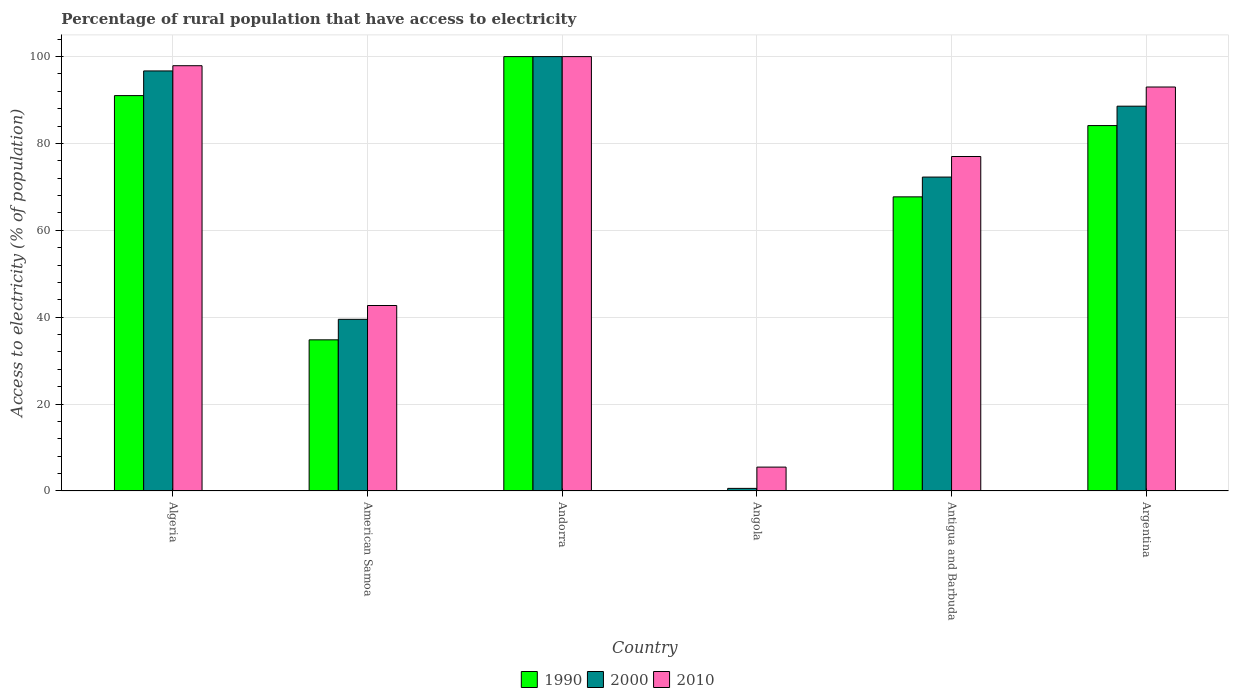Are the number of bars per tick equal to the number of legend labels?
Provide a short and direct response. Yes. How many bars are there on the 1st tick from the left?
Offer a very short reply. 3. How many bars are there on the 4th tick from the right?
Provide a succinct answer. 3. What is the label of the 1st group of bars from the left?
Ensure brevity in your answer.  Algeria. In how many cases, is the number of bars for a given country not equal to the number of legend labels?
Your answer should be compact. 0. What is the percentage of rural population that have access to electricity in 2010 in American Samoa?
Make the answer very short. 42.7. In which country was the percentage of rural population that have access to electricity in 2000 maximum?
Your answer should be compact. Andorra. In which country was the percentage of rural population that have access to electricity in 1990 minimum?
Your response must be concise. Angola. What is the total percentage of rural population that have access to electricity in 2010 in the graph?
Offer a very short reply. 416.1. What is the difference between the percentage of rural population that have access to electricity in 1990 in Andorra and that in Antigua and Barbuda?
Your answer should be very brief. 32.29. What is the difference between the percentage of rural population that have access to electricity in 1990 in Algeria and the percentage of rural population that have access to electricity in 2000 in Angola?
Your response must be concise. 90.42. What is the average percentage of rural population that have access to electricity in 1990 per country?
Provide a short and direct response. 62.96. What is the difference between the percentage of rural population that have access to electricity of/in 1990 and percentage of rural population that have access to electricity of/in 2010 in Argentina?
Your answer should be very brief. -8.88. What is the ratio of the percentage of rural population that have access to electricity in 2010 in American Samoa to that in Angola?
Your response must be concise. 7.76. What is the difference between the highest and the second highest percentage of rural population that have access to electricity in 1990?
Give a very brief answer. -8.98. What is the difference between the highest and the lowest percentage of rural population that have access to electricity in 1990?
Your answer should be compact. 99.9. In how many countries, is the percentage of rural population that have access to electricity in 2000 greater than the average percentage of rural population that have access to electricity in 2000 taken over all countries?
Make the answer very short. 4. Is the sum of the percentage of rural population that have access to electricity in 2010 in Antigua and Barbuda and Argentina greater than the maximum percentage of rural population that have access to electricity in 2000 across all countries?
Your answer should be compact. Yes. What does the 1st bar from the left in American Samoa represents?
Provide a short and direct response. 1990. Are all the bars in the graph horizontal?
Your response must be concise. No. How many countries are there in the graph?
Offer a terse response. 6. Are the values on the major ticks of Y-axis written in scientific E-notation?
Your response must be concise. No. Does the graph contain any zero values?
Your response must be concise. No. Where does the legend appear in the graph?
Offer a very short reply. Bottom center. How many legend labels are there?
Give a very brief answer. 3. How are the legend labels stacked?
Keep it short and to the point. Horizontal. What is the title of the graph?
Offer a terse response. Percentage of rural population that have access to electricity. Does "1993" appear as one of the legend labels in the graph?
Offer a terse response. No. What is the label or title of the X-axis?
Your answer should be very brief. Country. What is the label or title of the Y-axis?
Offer a terse response. Access to electricity (% of population). What is the Access to electricity (% of population) in 1990 in Algeria?
Make the answer very short. 91.02. What is the Access to electricity (% of population) in 2000 in Algeria?
Provide a succinct answer. 96.7. What is the Access to electricity (% of population) of 2010 in Algeria?
Give a very brief answer. 97.9. What is the Access to electricity (% of population) of 1990 in American Samoa?
Keep it short and to the point. 34.8. What is the Access to electricity (% of population) in 2000 in American Samoa?
Offer a very short reply. 39.52. What is the Access to electricity (% of population) in 2010 in American Samoa?
Your response must be concise. 42.7. What is the Access to electricity (% of population) of 1990 in Andorra?
Your answer should be very brief. 100. What is the Access to electricity (% of population) of 2010 in Andorra?
Ensure brevity in your answer.  100. What is the Access to electricity (% of population) of 1990 in Angola?
Provide a short and direct response. 0.1. What is the Access to electricity (% of population) in 2000 in Angola?
Provide a short and direct response. 0.6. What is the Access to electricity (% of population) in 1990 in Antigua and Barbuda?
Make the answer very short. 67.71. What is the Access to electricity (% of population) in 2000 in Antigua and Barbuda?
Keep it short and to the point. 72.27. What is the Access to electricity (% of population) in 2010 in Antigua and Barbuda?
Your response must be concise. 77. What is the Access to electricity (% of population) in 1990 in Argentina?
Make the answer very short. 84.12. What is the Access to electricity (% of population) in 2000 in Argentina?
Provide a succinct answer. 88.59. What is the Access to electricity (% of population) of 2010 in Argentina?
Your answer should be very brief. 93. What is the total Access to electricity (% of population) in 1990 in the graph?
Your answer should be compact. 377.75. What is the total Access to electricity (% of population) of 2000 in the graph?
Offer a very short reply. 397.67. What is the total Access to electricity (% of population) of 2010 in the graph?
Your answer should be compact. 416.1. What is the difference between the Access to electricity (% of population) of 1990 in Algeria and that in American Samoa?
Give a very brief answer. 56.22. What is the difference between the Access to electricity (% of population) of 2000 in Algeria and that in American Samoa?
Your answer should be compact. 57.18. What is the difference between the Access to electricity (% of population) of 2010 in Algeria and that in American Samoa?
Give a very brief answer. 55.2. What is the difference between the Access to electricity (% of population) in 1990 in Algeria and that in Andorra?
Keep it short and to the point. -8.98. What is the difference between the Access to electricity (% of population) in 2010 in Algeria and that in Andorra?
Offer a very short reply. -2.1. What is the difference between the Access to electricity (% of population) of 1990 in Algeria and that in Angola?
Give a very brief answer. 90.92. What is the difference between the Access to electricity (% of population) in 2000 in Algeria and that in Angola?
Offer a very short reply. 96.1. What is the difference between the Access to electricity (% of population) of 2010 in Algeria and that in Angola?
Offer a very short reply. 92.4. What is the difference between the Access to electricity (% of population) of 1990 in Algeria and that in Antigua and Barbuda?
Offer a very short reply. 23.31. What is the difference between the Access to electricity (% of population) of 2000 in Algeria and that in Antigua and Barbuda?
Your response must be concise. 24.43. What is the difference between the Access to electricity (% of population) in 2010 in Algeria and that in Antigua and Barbuda?
Offer a very short reply. 20.9. What is the difference between the Access to electricity (% of population) of 1990 in Algeria and that in Argentina?
Keep it short and to the point. 6.9. What is the difference between the Access to electricity (% of population) of 2000 in Algeria and that in Argentina?
Ensure brevity in your answer.  8.11. What is the difference between the Access to electricity (% of population) of 2010 in Algeria and that in Argentina?
Give a very brief answer. 4.9. What is the difference between the Access to electricity (% of population) in 1990 in American Samoa and that in Andorra?
Offer a terse response. -65.2. What is the difference between the Access to electricity (% of population) in 2000 in American Samoa and that in Andorra?
Give a very brief answer. -60.48. What is the difference between the Access to electricity (% of population) of 2010 in American Samoa and that in Andorra?
Your answer should be very brief. -57.3. What is the difference between the Access to electricity (% of population) of 1990 in American Samoa and that in Angola?
Ensure brevity in your answer.  34.7. What is the difference between the Access to electricity (% of population) in 2000 in American Samoa and that in Angola?
Provide a succinct answer. 38.92. What is the difference between the Access to electricity (% of population) in 2010 in American Samoa and that in Angola?
Keep it short and to the point. 37.2. What is the difference between the Access to electricity (% of population) of 1990 in American Samoa and that in Antigua and Barbuda?
Ensure brevity in your answer.  -32.91. What is the difference between the Access to electricity (% of population) in 2000 in American Samoa and that in Antigua and Barbuda?
Keep it short and to the point. -32.74. What is the difference between the Access to electricity (% of population) in 2010 in American Samoa and that in Antigua and Barbuda?
Offer a terse response. -34.3. What is the difference between the Access to electricity (% of population) of 1990 in American Samoa and that in Argentina?
Ensure brevity in your answer.  -49.32. What is the difference between the Access to electricity (% of population) of 2000 in American Samoa and that in Argentina?
Make the answer very short. -49.07. What is the difference between the Access to electricity (% of population) of 2010 in American Samoa and that in Argentina?
Keep it short and to the point. -50.3. What is the difference between the Access to electricity (% of population) in 1990 in Andorra and that in Angola?
Provide a succinct answer. 99.9. What is the difference between the Access to electricity (% of population) in 2000 in Andorra and that in Angola?
Give a very brief answer. 99.4. What is the difference between the Access to electricity (% of population) in 2010 in Andorra and that in Angola?
Your response must be concise. 94.5. What is the difference between the Access to electricity (% of population) in 1990 in Andorra and that in Antigua and Barbuda?
Make the answer very short. 32.29. What is the difference between the Access to electricity (% of population) in 2000 in Andorra and that in Antigua and Barbuda?
Keep it short and to the point. 27.73. What is the difference between the Access to electricity (% of population) in 2010 in Andorra and that in Antigua and Barbuda?
Your answer should be compact. 23. What is the difference between the Access to electricity (% of population) in 1990 in Andorra and that in Argentina?
Provide a succinct answer. 15.88. What is the difference between the Access to electricity (% of population) in 2000 in Andorra and that in Argentina?
Offer a very short reply. 11.41. What is the difference between the Access to electricity (% of population) of 1990 in Angola and that in Antigua and Barbuda?
Keep it short and to the point. -67.61. What is the difference between the Access to electricity (% of population) in 2000 in Angola and that in Antigua and Barbuda?
Your answer should be compact. -71.67. What is the difference between the Access to electricity (% of population) of 2010 in Angola and that in Antigua and Barbuda?
Your answer should be compact. -71.5. What is the difference between the Access to electricity (% of population) of 1990 in Angola and that in Argentina?
Your answer should be very brief. -84.02. What is the difference between the Access to electricity (% of population) of 2000 in Angola and that in Argentina?
Provide a succinct answer. -87.99. What is the difference between the Access to electricity (% of population) of 2010 in Angola and that in Argentina?
Provide a succinct answer. -87.5. What is the difference between the Access to electricity (% of population) of 1990 in Antigua and Barbuda and that in Argentina?
Offer a terse response. -16.41. What is the difference between the Access to electricity (% of population) in 2000 in Antigua and Barbuda and that in Argentina?
Offer a terse response. -16.32. What is the difference between the Access to electricity (% of population) in 1990 in Algeria and the Access to electricity (% of population) in 2000 in American Samoa?
Your answer should be compact. 51.5. What is the difference between the Access to electricity (% of population) of 1990 in Algeria and the Access to electricity (% of population) of 2010 in American Samoa?
Your answer should be compact. 48.32. What is the difference between the Access to electricity (% of population) of 2000 in Algeria and the Access to electricity (% of population) of 2010 in American Samoa?
Your answer should be compact. 54. What is the difference between the Access to electricity (% of population) of 1990 in Algeria and the Access to electricity (% of population) of 2000 in Andorra?
Your response must be concise. -8.98. What is the difference between the Access to electricity (% of population) of 1990 in Algeria and the Access to electricity (% of population) of 2010 in Andorra?
Provide a short and direct response. -8.98. What is the difference between the Access to electricity (% of population) of 1990 in Algeria and the Access to electricity (% of population) of 2000 in Angola?
Provide a short and direct response. 90.42. What is the difference between the Access to electricity (% of population) in 1990 in Algeria and the Access to electricity (% of population) in 2010 in Angola?
Keep it short and to the point. 85.52. What is the difference between the Access to electricity (% of population) in 2000 in Algeria and the Access to electricity (% of population) in 2010 in Angola?
Your answer should be very brief. 91.2. What is the difference between the Access to electricity (% of population) of 1990 in Algeria and the Access to electricity (% of population) of 2000 in Antigua and Barbuda?
Offer a terse response. 18.75. What is the difference between the Access to electricity (% of population) of 1990 in Algeria and the Access to electricity (% of population) of 2010 in Antigua and Barbuda?
Give a very brief answer. 14.02. What is the difference between the Access to electricity (% of population) in 2000 in Algeria and the Access to electricity (% of population) in 2010 in Antigua and Barbuda?
Ensure brevity in your answer.  19.7. What is the difference between the Access to electricity (% of population) of 1990 in Algeria and the Access to electricity (% of population) of 2000 in Argentina?
Your answer should be compact. 2.43. What is the difference between the Access to electricity (% of population) in 1990 in Algeria and the Access to electricity (% of population) in 2010 in Argentina?
Make the answer very short. -1.98. What is the difference between the Access to electricity (% of population) in 2000 in Algeria and the Access to electricity (% of population) in 2010 in Argentina?
Keep it short and to the point. 3.7. What is the difference between the Access to electricity (% of population) in 1990 in American Samoa and the Access to electricity (% of population) in 2000 in Andorra?
Provide a short and direct response. -65.2. What is the difference between the Access to electricity (% of population) in 1990 in American Samoa and the Access to electricity (% of population) in 2010 in Andorra?
Offer a terse response. -65.2. What is the difference between the Access to electricity (% of population) of 2000 in American Samoa and the Access to electricity (% of population) of 2010 in Andorra?
Give a very brief answer. -60.48. What is the difference between the Access to electricity (% of population) in 1990 in American Samoa and the Access to electricity (% of population) in 2000 in Angola?
Your response must be concise. 34.2. What is the difference between the Access to electricity (% of population) of 1990 in American Samoa and the Access to electricity (% of population) of 2010 in Angola?
Make the answer very short. 29.3. What is the difference between the Access to electricity (% of population) in 2000 in American Samoa and the Access to electricity (% of population) in 2010 in Angola?
Your answer should be very brief. 34.02. What is the difference between the Access to electricity (% of population) in 1990 in American Samoa and the Access to electricity (% of population) in 2000 in Antigua and Barbuda?
Your answer should be very brief. -37.47. What is the difference between the Access to electricity (% of population) in 1990 in American Samoa and the Access to electricity (% of population) in 2010 in Antigua and Barbuda?
Provide a short and direct response. -42.2. What is the difference between the Access to electricity (% of population) of 2000 in American Samoa and the Access to electricity (% of population) of 2010 in Antigua and Barbuda?
Ensure brevity in your answer.  -37.48. What is the difference between the Access to electricity (% of population) in 1990 in American Samoa and the Access to electricity (% of population) in 2000 in Argentina?
Your answer should be compact. -53.79. What is the difference between the Access to electricity (% of population) of 1990 in American Samoa and the Access to electricity (% of population) of 2010 in Argentina?
Your answer should be very brief. -58.2. What is the difference between the Access to electricity (% of population) in 2000 in American Samoa and the Access to electricity (% of population) in 2010 in Argentina?
Provide a short and direct response. -53.48. What is the difference between the Access to electricity (% of population) of 1990 in Andorra and the Access to electricity (% of population) of 2000 in Angola?
Your response must be concise. 99.4. What is the difference between the Access to electricity (% of population) of 1990 in Andorra and the Access to electricity (% of population) of 2010 in Angola?
Your answer should be very brief. 94.5. What is the difference between the Access to electricity (% of population) in 2000 in Andorra and the Access to electricity (% of population) in 2010 in Angola?
Make the answer very short. 94.5. What is the difference between the Access to electricity (% of population) in 1990 in Andorra and the Access to electricity (% of population) in 2000 in Antigua and Barbuda?
Make the answer very short. 27.73. What is the difference between the Access to electricity (% of population) of 1990 in Andorra and the Access to electricity (% of population) of 2010 in Antigua and Barbuda?
Offer a terse response. 23. What is the difference between the Access to electricity (% of population) in 1990 in Andorra and the Access to electricity (% of population) in 2000 in Argentina?
Your answer should be compact. 11.41. What is the difference between the Access to electricity (% of population) in 2000 in Andorra and the Access to electricity (% of population) in 2010 in Argentina?
Provide a short and direct response. 7. What is the difference between the Access to electricity (% of population) of 1990 in Angola and the Access to electricity (% of population) of 2000 in Antigua and Barbuda?
Your response must be concise. -72.17. What is the difference between the Access to electricity (% of population) of 1990 in Angola and the Access to electricity (% of population) of 2010 in Antigua and Barbuda?
Your response must be concise. -76.9. What is the difference between the Access to electricity (% of population) of 2000 in Angola and the Access to electricity (% of population) of 2010 in Antigua and Barbuda?
Keep it short and to the point. -76.4. What is the difference between the Access to electricity (% of population) in 1990 in Angola and the Access to electricity (% of population) in 2000 in Argentina?
Your response must be concise. -88.49. What is the difference between the Access to electricity (% of population) of 1990 in Angola and the Access to electricity (% of population) of 2010 in Argentina?
Give a very brief answer. -92.9. What is the difference between the Access to electricity (% of population) in 2000 in Angola and the Access to electricity (% of population) in 2010 in Argentina?
Your response must be concise. -92.4. What is the difference between the Access to electricity (% of population) in 1990 in Antigua and Barbuda and the Access to electricity (% of population) in 2000 in Argentina?
Your answer should be very brief. -20.88. What is the difference between the Access to electricity (% of population) of 1990 in Antigua and Barbuda and the Access to electricity (% of population) of 2010 in Argentina?
Provide a succinct answer. -25.29. What is the difference between the Access to electricity (% of population) in 2000 in Antigua and Barbuda and the Access to electricity (% of population) in 2010 in Argentina?
Your response must be concise. -20.73. What is the average Access to electricity (% of population) in 1990 per country?
Offer a terse response. 62.96. What is the average Access to electricity (% of population) in 2000 per country?
Your response must be concise. 66.28. What is the average Access to electricity (% of population) in 2010 per country?
Your answer should be compact. 69.35. What is the difference between the Access to electricity (% of population) of 1990 and Access to electricity (% of population) of 2000 in Algeria?
Your response must be concise. -5.68. What is the difference between the Access to electricity (% of population) in 1990 and Access to electricity (% of population) in 2010 in Algeria?
Offer a terse response. -6.88. What is the difference between the Access to electricity (% of population) in 1990 and Access to electricity (% of population) in 2000 in American Samoa?
Your answer should be very brief. -4.72. What is the difference between the Access to electricity (% of population) of 1990 and Access to electricity (% of population) of 2010 in American Samoa?
Make the answer very short. -7.9. What is the difference between the Access to electricity (% of population) in 2000 and Access to electricity (% of population) in 2010 in American Samoa?
Provide a succinct answer. -3.18. What is the difference between the Access to electricity (% of population) of 1990 and Access to electricity (% of population) of 2000 in Andorra?
Ensure brevity in your answer.  0. What is the difference between the Access to electricity (% of population) in 1990 and Access to electricity (% of population) in 2010 in Andorra?
Provide a short and direct response. 0. What is the difference between the Access to electricity (% of population) of 2000 and Access to electricity (% of population) of 2010 in Angola?
Offer a terse response. -4.9. What is the difference between the Access to electricity (% of population) of 1990 and Access to electricity (% of population) of 2000 in Antigua and Barbuda?
Provide a succinct answer. -4.55. What is the difference between the Access to electricity (% of population) of 1990 and Access to electricity (% of population) of 2010 in Antigua and Barbuda?
Provide a short and direct response. -9.29. What is the difference between the Access to electricity (% of population) in 2000 and Access to electricity (% of population) in 2010 in Antigua and Barbuda?
Your answer should be compact. -4.74. What is the difference between the Access to electricity (% of population) in 1990 and Access to electricity (% of population) in 2000 in Argentina?
Offer a very short reply. -4.47. What is the difference between the Access to electricity (% of population) of 1990 and Access to electricity (% of population) of 2010 in Argentina?
Your response must be concise. -8.88. What is the difference between the Access to electricity (% of population) of 2000 and Access to electricity (% of population) of 2010 in Argentina?
Make the answer very short. -4.41. What is the ratio of the Access to electricity (% of population) in 1990 in Algeria to that in American Samoa?
Your answer should be compact. 2.62. What is the ratio of the Access to electricity (% of population) of 2000 in Algeria to that in American Samoa?
Your response must be concise. 2.45. What is the ratio of the Access to electricity (% of population) of 2010 in Algeria to that in American Samoa?
Provide a succinct answer. 2.29. What is the ratio of the Access to electricity (% of population) of 1990 in Algeria to that in Andorra?
Ensure brevity in your answer.  0.91. What is the ratio of the Access to electricity (% of population) in 1990 in Algeria to that in Angola?
Offer a terse response. 910.2. What is the ratio of the Access to electricity (% of population) in 2000 in Algeria to that in Angola?
Give a very brief answer. 161.17. What is the ratio of the Access to electricity (% of population) of 1990 in Algeria to that in Antigua and Barbuda?
Keep it short and to the point. 1.34. What is the ratio of the Access to electricity (% of population) of 2000 in Algeria to that in Antigua and Barbuda?
Ensure brevity in your answer.  1.34. What is the ratio of the Access to electricity (% of population) of 2010 in Algeria to that in Antigua and Barbuda?
Your answer should be compact. 1.27. What is the ratio of the Access to electricity (% of population) in 1990 in Algeria to that in Argentina?
Give a very brief answer. 1.08. What is the ratio of the Access to electricity (% of population) in 2000 in Algeria to that in Argentina?
Give a very brief answer. 1.09. What is the ratio of the Access to electricity (% of population) in 2010 in Algeria to that in Argentina?
Your answer should be very brief. 1.05. What is the ratio of the Access to electricity (% of population) in 1990 in American Samoa to that in Andorra?
Ensure brevity in your answer.  0.35. What is the ratio of the Access to electricity (% of population) of 2000 in American Samoa to that in Andorra?
Provide a short and direct response. 0.4. What is the ratio of the Access to electricity (% of population) of 2010 in American Samoa to that in Andorra?
Give a very brief answer. 0.43. What is the ratio of the Access to electricity (% of population) in 1990 in American Samoa to that in Angola?
Your response must be concise. 347.98. What is the ratio of the Access to electricity (% of population) in 2000 in American Samoa to that in Angola?
Give a very brief answer. 65.87. What is the ratio of the Access to electricity (% of population) in 2010 in American Samoa to that in Angola?
Your answer should be compact. 7.76. What is the ratio of the Access to electricity (% of population) in 1990 in American Samoa to that in Antigua and Barbuda?
Your answer should be compact. 0.51. What is the ratio of the Access to electricity (% of population) of 2000 in American Samoa to that in Antigua and Barbuda?
Keep it short and to the point. 0.55. What is the ratio of the Access to electricity (% of population) in 2010 in American Samoa to that in Antigua and Barbuda?
Provide a short and direct response. 0.55. What is the ratio of the Access to electricity (% of population) in 1990 in American Samoa to that in Argentina?
Offer a very short reply. 0.41. What is the ratio of the Access to electricity (% of population) in 2000 in American Samoa to that in Argentina?
Your answer should be very brief. 0.45. What is the ratio of the Access to electricity (% of population) in 2010 in American Samoa to that in Argentina?
Your answer should be very brief. 0.46. What is the ratio of the Access to electricity (% of population) of 2000 in Andorra to that in Angola?
Ensure brevity in your answer.  166.67. What is the ratio of the Access to electricity (% of population) in 2010 in Andorra to that in Angola?
Your answer should be very brief. 18.18. What is the ratio of the Access to electricity (% of population) of 1990 in Andorra to that in Antigua and Barbuda?
Your answer should be very brief. 1.48. What is the ratio of the Access to electricity (% of population) in 2000 in Andorra to that in Antigua and Barbuda?
Ensure brevity in your answer.  1.38. What is the ratio of the Access to electricity (% of population) in 2010 in Andorra to that in Antigua and Barbuda?
Provide a succinct answer. 1.3. What is the ratio of the Access to electricity (% of population) of 1990 in Andorra to that in Argentina?
Offer a terse response. 1.19. What is the ratio of the Access to electricity (% of population) in 2000 in Andorra to that in Argentina?
Provide a short and direct response. 1.13. What is the ratio of the Access to electricity (% of population) in 2010 in Andorra to that in Argentina?
Offer a terse response. 1.08. What is the ratio of the Access to electricity (% of population) of 1990 in Angola to that in Antigua and Barbuda?
Give a very brief answer. 0. What is the ratio of the Access to electricity (% of population) of 2000 in Angola to that in Antigua and Barbuda?
Give a very brief answer. 0.01. What is the ratio of the Access to electricity (% of population) in 2010 in Angola to that in Antigua and Barbuda?
Provide a short and direct response. 0.07. What is the ratio of the Access to electricity (% of population) of 1990 in Angola to that in Argentina?
Make the answer very short. 0. What is the ratio of the Access to electricity (% of population) in 2000 in Angola to that in Argentina?
Keep it short and to the point. 0.01. What is the ratio of the Access to electricity (% of population) of 2010 in Angola to that in Argentina?
Ensure brevity in your answer.  0.06. What is the ratio of the Access to electricity (% of population) of 1990 in Antigua and Barbuda to that in Argentina?
Give a very brief answer. 0.8. What is the ratio of the Access to electricity (% of population) in 2000 in Antigua and Barbuda to that in Argentina?
Provide a succinct answer. 0.82. What is the ratio of the Access to electricity (% of population) of 2010 in Antigua and Barbuda to that in Argentina?
Your answer should be compact. 0.83. What is the difference between the highest and the second highest Access to electricity (% of population) in 1990?
Keep it short and to the point. 8.98. What is the difference between the highest and the second highest Access to electricity (% of population) of 2000?
Keep it short and to the point. 3.3. What is the difference between the highest and the lowest Access to electricity (% of population) of 1990?
Your answer should be very brief. 99.9. What is the difference between the highest and the lowest Access to electricity (% of population) in 2000?
Ensure brevity in your answer.  99.4. What is the difference between the highest and the lowest Access to electricity (% of population) in 2010?
Keep it short and to the point. 94.5. 